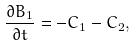Convert formula to latex. <formula><loc_0><loc_0><loc_500><loc_500>\frac { \partial B _ { 1 } } { \partial t } = - C _ { 1 } - C _ { 2 } ,</formula> 